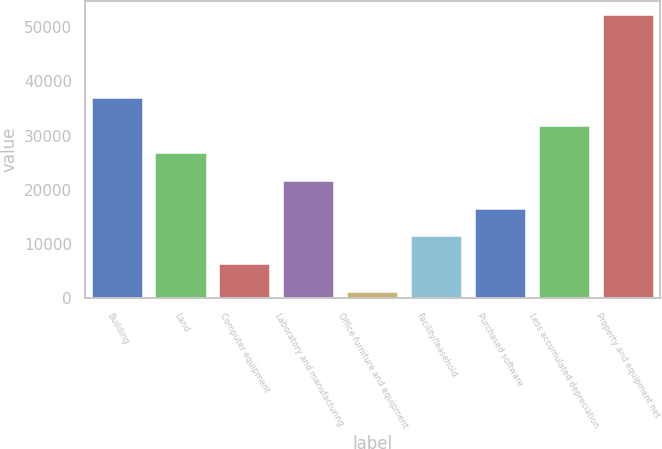Convert chart to OTSL. <chart><loc_0><loc_0><loc_500><loc_500><bar_chart><fcel>Building<fcel>Land<fcel>Computer equipment<fcel>Laboratory and manufacturing<fcel>Office furniture and equipment<fcel>Facility/leasehold<fcel>Purchased software<fcel>Less accumulated depreciation<fcel>Property and equipment net<nl><fcel>36908.5<fcel>26697.5<fcel>6275.5<fcel>21592<fcel>1170<fcel>11381<fcel>16486.5<fcel>31803<fcel>52225<nl></chart> 